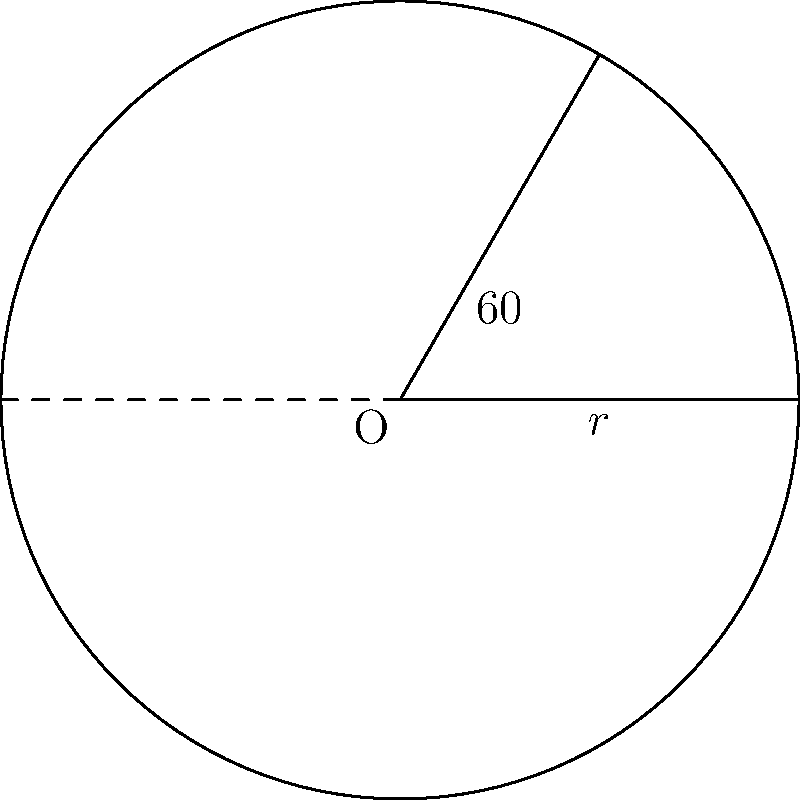As the designer for your nonprofit organization's new logo, you've created a circular design with a radius of 10 inches. The logo includes a sector with a central angle of 60°. Calculate the area of this sector using trigonometric functions. To calculate the area of a sector in a circle, we can follow these steps:

1) The formula for the area of a sector is:
   $$A = \frac{1}{2} r^2 \theta$$
   where $r$ is the radius and $\theta$ is the central angle in radians.

2) We're given the angle in degrees (60°), so we need to convert it to radians:
   $$\theta = 60° \times \frac{\pi}{180°} = \frac{\pi}{3} \text{ radians}$$

3) We're given the radius as 10 inches.

4) Now we can substitute these values into our formula:
   $$A = \frac{1}{2} \times 10^2 \times \frac{\pi}{3}$$

5) Simplify:
   $$A = 50 \times \frac{\pi}{3} = \frac{50\pi}{3} \approx 52.36 \text{ square inches}$$

Thus, the area of the sector is $\frac{50\pi}{3}$ square inches.
Answer: $\frac{50\pi}{3}$ square inches 